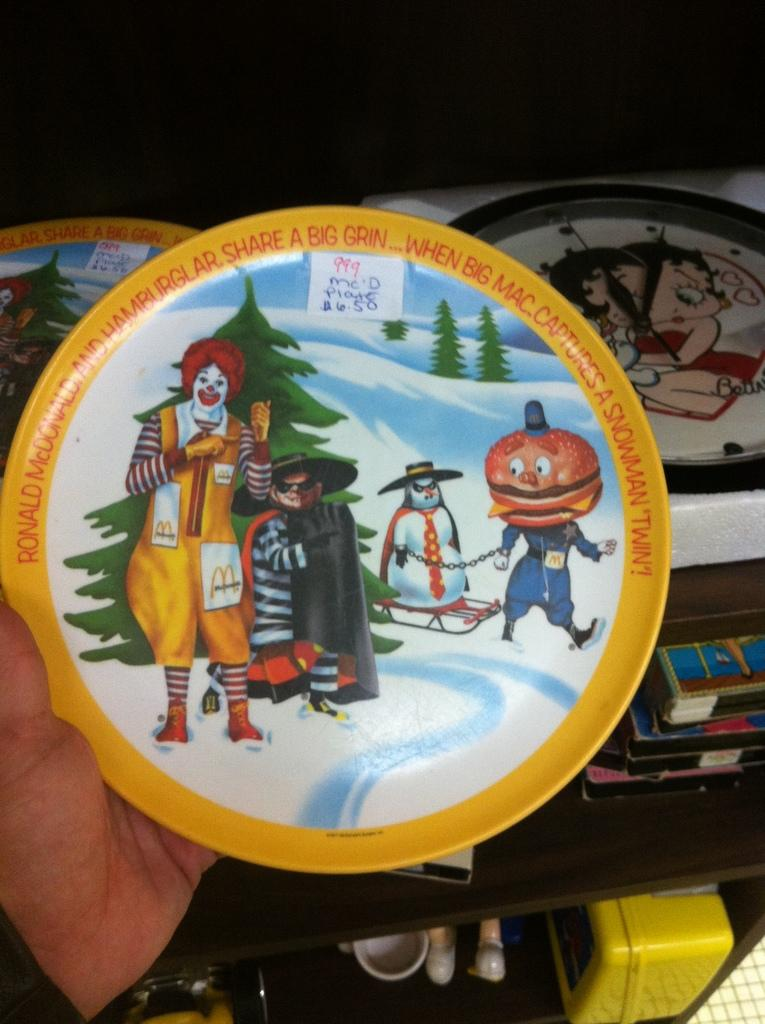What is on the plate that is being held in the image? There is a plate with paintings in the image. Who is holding the plate with paintings? The plate is held in a person's hand. Are there any other plates visible in the image? Yes, there are other plates visible in the image. What can be seen on the wooden cupboard in the image? There are other objects on a wooden cupboard in the image. How does the steam rise from the wooden cupboard in the image? There is no steam present in the image; it is a wooden cupboard with objects on it. 